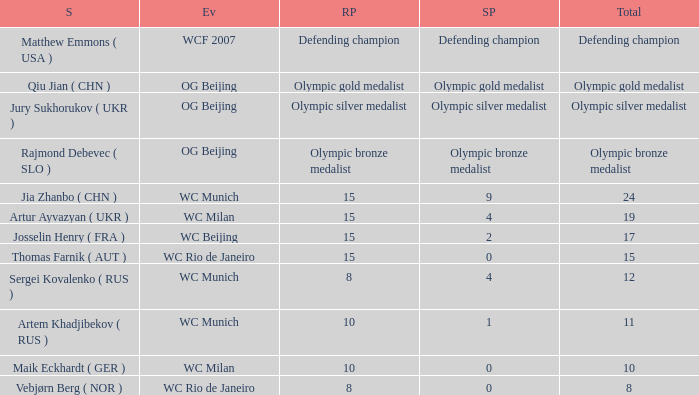With a total of 11, and 10 rank points, what are the score points? 1.0. 